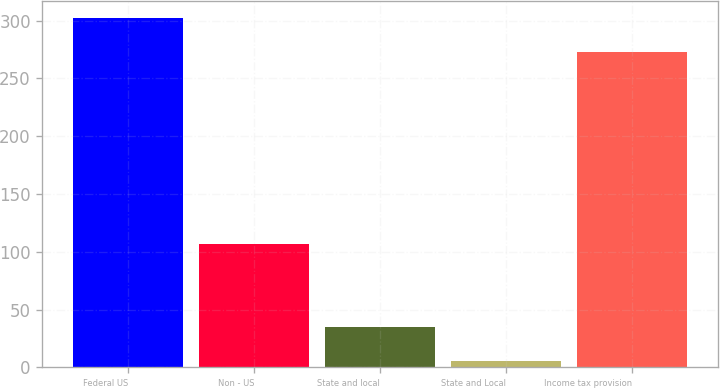<chart> <loc_0><loc_0><loc_500><loc_500><bar_chart><fcel>Federal US<fcel>Non - US<fcel>State and local<fcel>State and Local<fcel>Income tax provision<nl><fcel>302.36<fcel>106.6<fcel>34.86<fcel>5.7<fcel>273.2<nl></chart> 